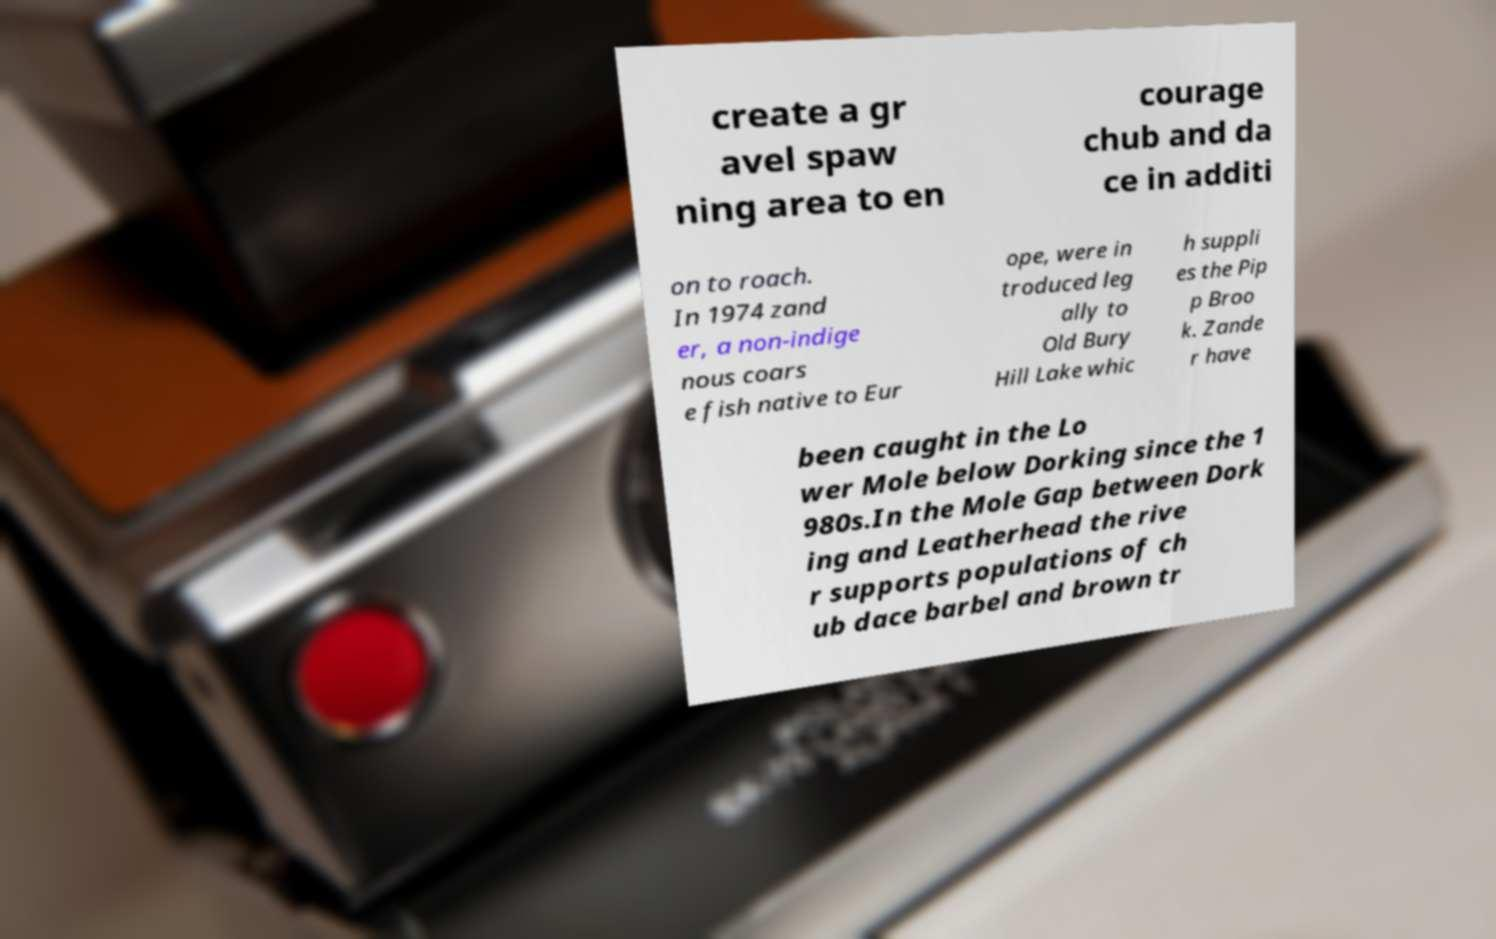Can you accurately transcribe the text from the provided image for me? create a gr avel spaw ning area to en courage chub and da ce in additi on to roach. In 1974 zand er, a non-indige nous coars e fish native to Eur ope, were in troduced leg ally to Old Bury Hill Lake whic h suppli es the Pip p Broo k. Zande r have been caught in the Lo wer Mole below Dorking since the 1 980s.In the Mole Gap between Dork ing and Leatherhead the rive r supports populations of ch ub dace barbel and brown tr 